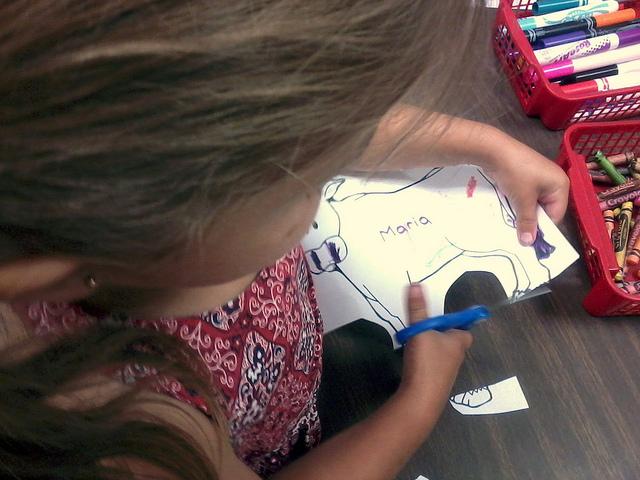Is this little girl bored?
Be succinct. No. What is written on the cow picture?
Write a very short answer. Maria. Which hand is the girl holding the scissors in?
Concise answer only. Right. 